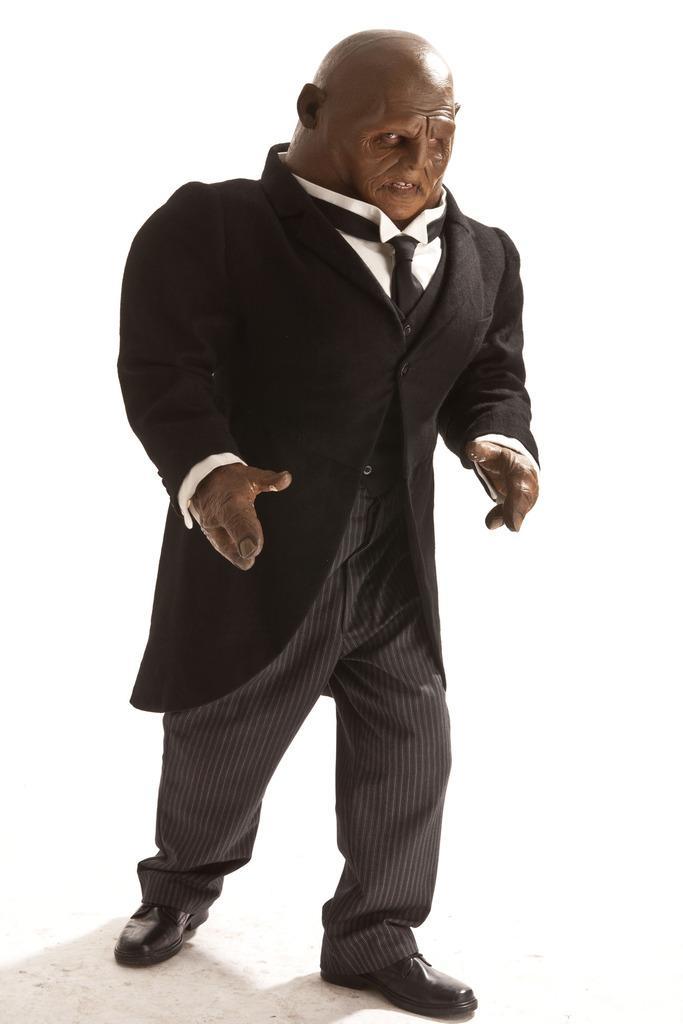Can you describe this image briefly? In this image we can see a statue of a person and the background is white. 